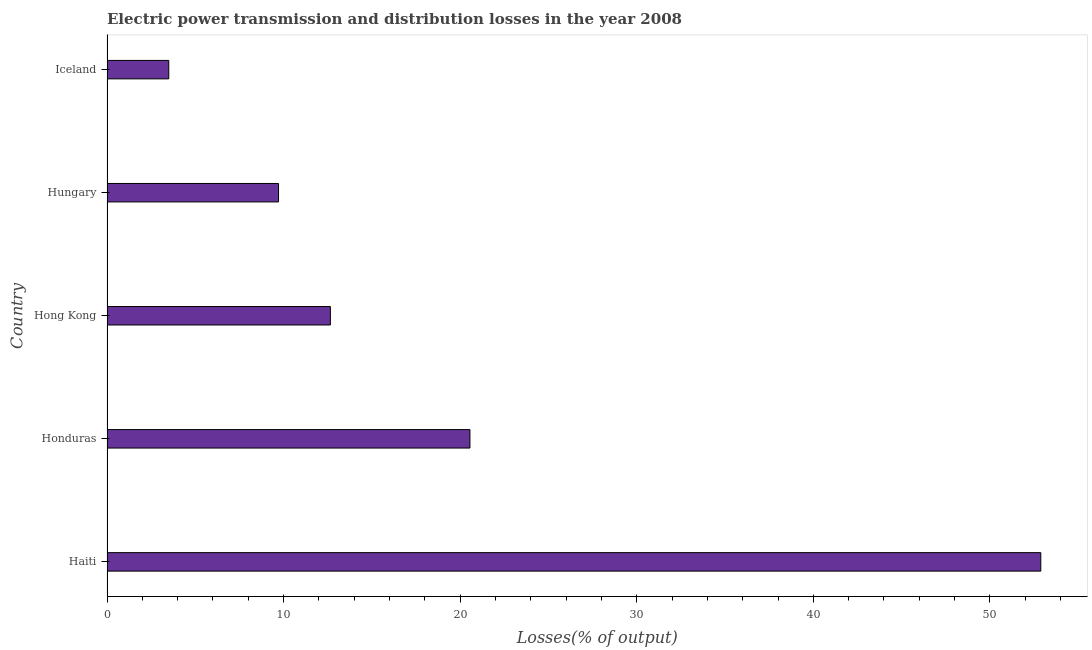Does the graph contain grids?
Offer a terse response. No. What is the title of the graph?
Offer a terse response. Electric power transmission and distribution losses in the year 2008. What is the label or title of the X-axis?
Ensure brevity in your answer.  Losses(% of output). What is the electric power transmission and distribution losses in Honduras?
Ensure brevity in your answer.  20.55. Across all countries, what is the maximum electric power transmission and distribution losses?
Ensure brevity in your answer.  52.88. Across all countries, what is the minimum electric power transmission and distribution losses?
Give a very brief answer. 3.5. In which country was the electric power transmission and distribution losses maximum?
Provide a succinct answer. Haiti. In which country was the electric power transmission and distribution losses minimum?
Your answer should be compact. Iceland. What is the sum of the electric power transmission and distribution losses?
Ensure brevity in your answer.  99.29. What is the difference between the electric power transmission and distribution losses in Hong Kong and Hungary?
Make the answer very short. 2.94. What is the average electric power transmission and distribution losses per country?
Ensure brevity in your answer.  19.86. What is the median electric power transmission and distribution losses?
Your response must be concise. 12.65. What is the ratio of the electric power transmission and distribution losses in Haiti to that in Hong Kong?
Provide a short and direct response. 4.18. Is the electric power transmission and distribution losses in Haiti less than that in Hungary?
Provide a succinct answer. No. Is the difference between the electric power transmission and distribution losses in Hong Kong and Hungary greater than the difference between any two countries?
Ensure brevity in your answer.  No. What is the difference between the highest and the second highest electric power transmission and distribution losses?
Provide a succinct answer. 32.33. What is the difference between the highest and the lowest electric power transmission and distribution losses?
Your answer should be compact. 49.38. In how many countries, is the electric power transmission and distribution losses greater than the average electric power transmission and distribution losses taken over all countries?
Give a very brief answer. 2. What is the Losses(% of output) of Haiti?
Offer a very short reply. 52.88. What is the Losses(% of output) of Honduras?
Your response must be concise. 20.55. What is the Losses(% of output) in Hong Kong?
Make the answer very short. 12.65. What is the Losses(% of output) of Hungary?
Your answer should be very brief. 9.71. What is the Losses(% of output) of Iceland?
Give a very brief answer. 3.5. What is the difference between the Losses(% of output) in Haiti and Honduras?
Provide a succinct answer. 32.33. What is the difference between the Losses(% of output) in Haiti and Hong Kong?
Provide a short and direct response. 40.23. What is the difference between the Losses(% of output) in Haiti and Hungary?
Give a very brief answer. 43.17. What is the difference between the Losses(% of output) in Haiti and Iceland?
Your answer should be compact. 49.38. What is the difference between the Losses(% of output) in Honduras and Hong Kong?
Make the answer very short. 7.9. What is the difference between the Losses(% of output) in Honduras and Hungary?
Keep it short and to the point. 10.84. What is the difference between the Losses(% of output) in Honduras and Iceland?
Make the answer very short. 17.05. What is the difference between the Losses(% of output) in Hong Kong and Hungary?
Offer a terse response. 2.94. What is the difference between the Losses(% of output) in Hong Kong and Iceland?
Give a very brief answer. 9.15. What is the difference between the Losses(% of output) in Hungary and Iceland?
Make the answer very short. 6.22. What is the ratio of the Losses(% of output) in Haiti to that in Honduras?
Keep it short and to the point. 2.57. What is the ratio of the Losses(% of output) in Haiti to that in Hong Kong?
Give a very brief answer. 4.18. What is the ratio of the Losses(% of output) in Haiti to that in Hungary?
Give a very brief answer. 5.44. What is the ratio of the Losses(% of output) in Haiti to that in Iceland?
Make the answer very short. 15.12. What is the ratio of the Losses(% of output) in Honduras to that in Hong Kong?
Offer a very short reply. 1.62. What is the ratio of the Losses(% of output) in Honduras to that in Hungary?
Ensure brevity in your answer.  2.12. What is the ratio of the Losses(% of output) in Honduras to that in Iceland?
Your answer should be very brief. 5.88. What is the ratio of the Losses(% of output) in Hong Kong to that in Hungary?
Offer a very short reply. 1.3. What is the ratio of the Losses(% of output) in Hong Kong to that in Iceland?
Your answer should be compact. 3.62. What is the ratio of the Losses(% of output) in Hungary to that in Iceland?
Give a very brief answer. 2.78. 